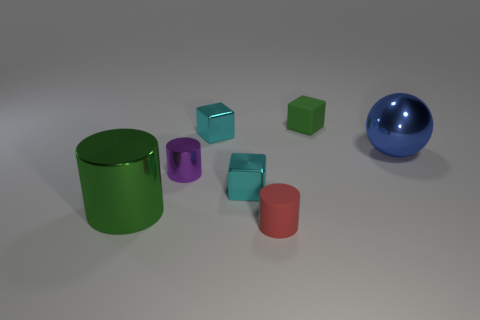What number of other tiny things have the same shape as the purple metallic object?
Give a very brief answer. 1. Are there the same number of red things in front of the tiny rubber cylinder and big shiny cylinders behind the big green cylinder?
Offer a very short reply. Yes. Are there any gray cubes?
Provide a short and direct response. No. There is a rubber cube that is behind the tiny cyan object that is behind the large thing that is on the right side of the matte cylinder; how big is it?
Offer a terse response. Small. There is a red matte object that is the same size as the matte cube; what shape is it?
Provide a short and direct response. Cylinder. Is there any other thing that is made of the same material as the purple cylinder?
Give a very brief answer. Yes. What number of things are tiny cyan objects that are behind the big blue object or purple cylinders?
Offer a very short reply. 2. Are there any tiny cyan metal things to the right of the shiny object that is on the right side of the cube that is right of the red cylinder?
Offer a terse response. No. How many green things are there?
Provide a short and direct response. 2. What number of objects are large things on the right side of the green block or tiny objects in front of the tiny green block?
Keep it short and to the point. 5. 